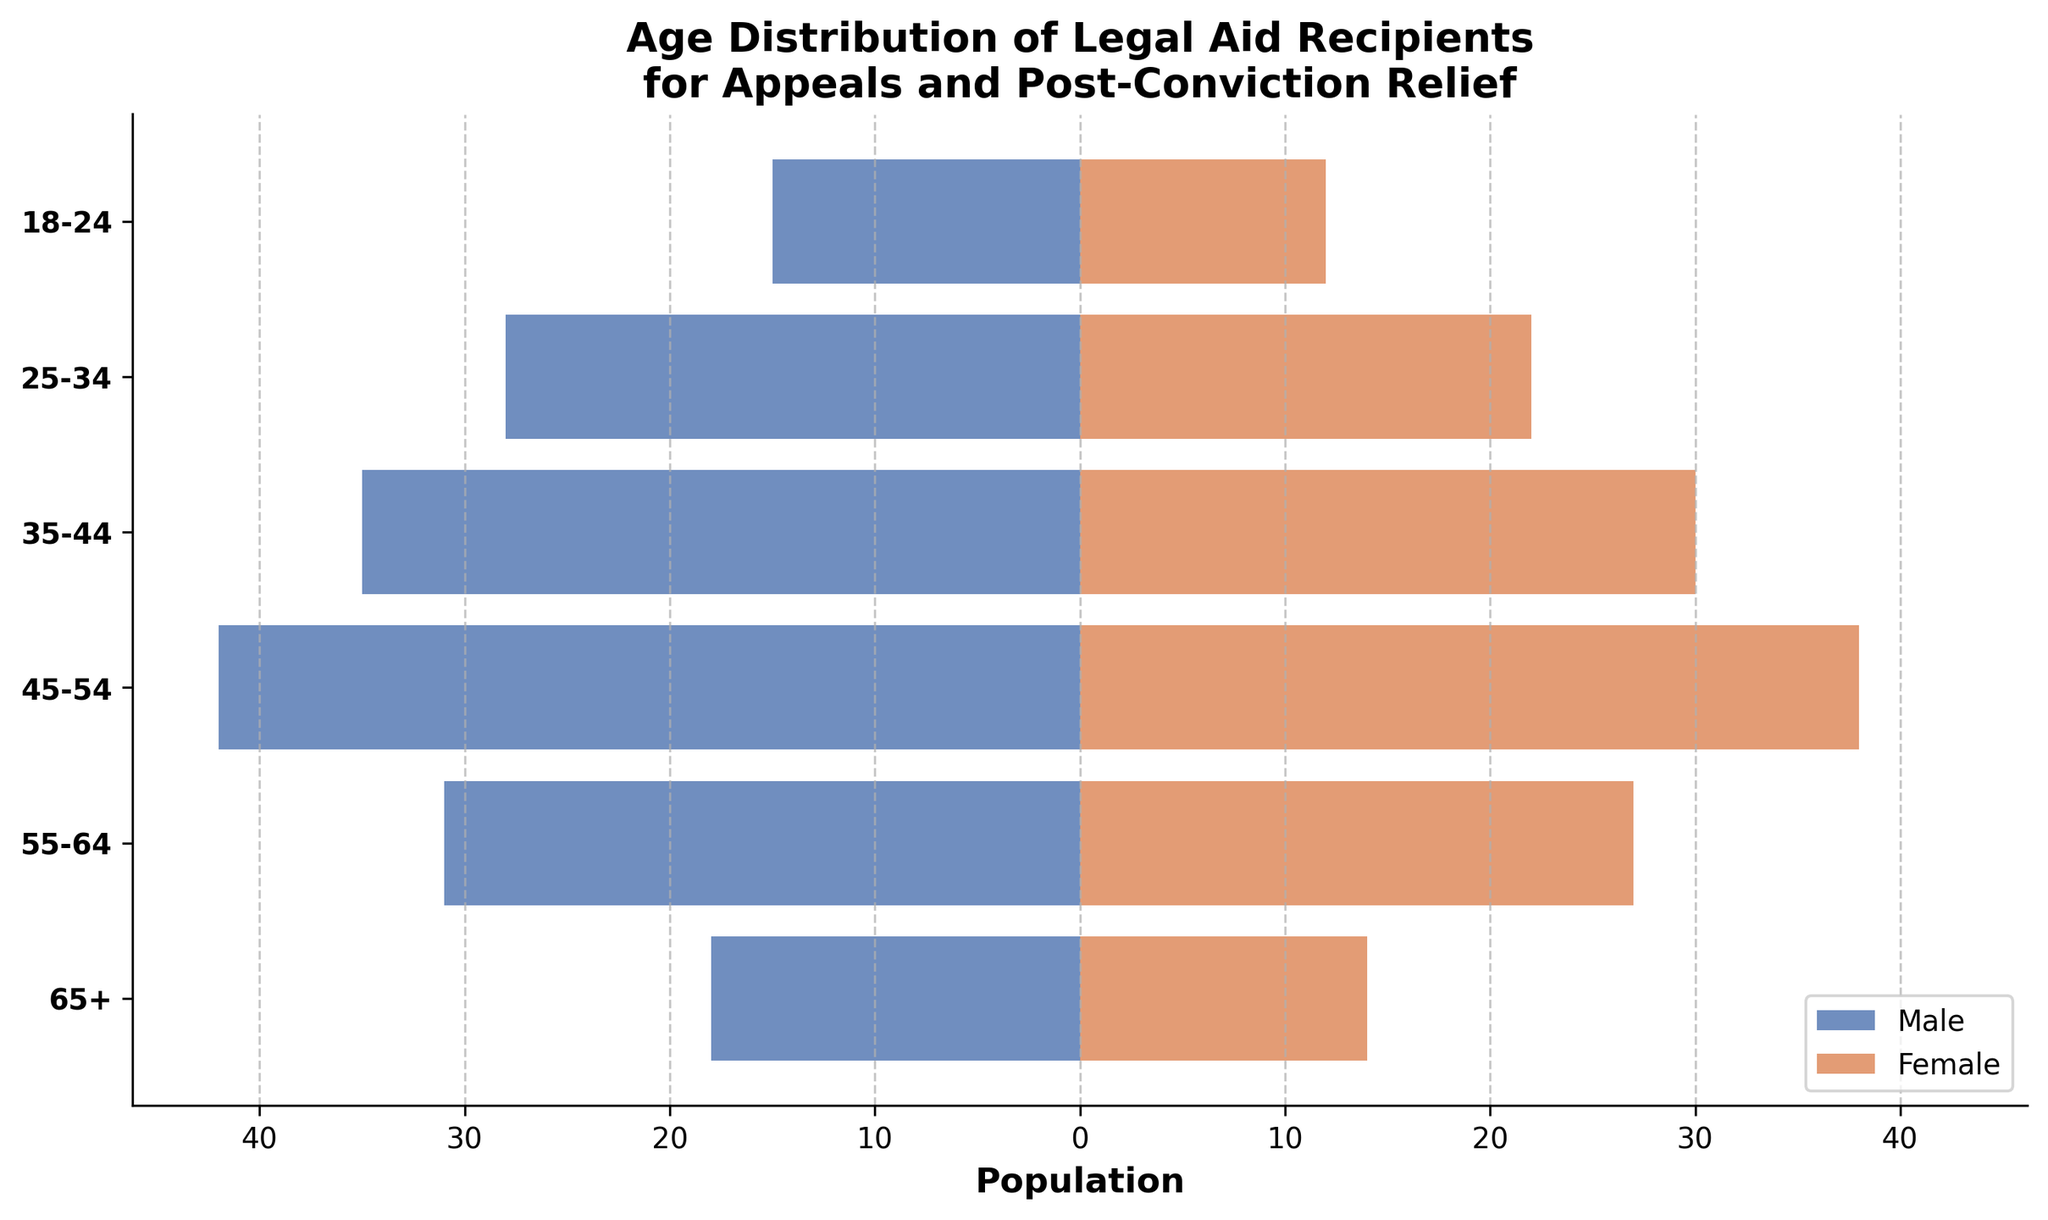What is the title of the figure? The title is usually displayed at the top of the figure. In this case, it clearly states the subject of the data presented.
Answer: Age Distribution of Legal Aid Recipients for Appeals and Post-Conviction Relief What age group has the highest number of males receiving legal aid? Look for the longest bar on the male side and identify its corresponding age group on the y-axis.
Answer: 45-54 What is the total number of females in the 35-44 and 45-54 age groups? Find the values for females in these two age groups and add them together. 35-44 has 30, and 45-54 has 38. So, the total is 30 + 38.
Answer: 68 Which gender has more recipients in the 55-64 age group? Compare the lengths of the bars for males and females in the 55-64 age group.
Answer: Male How many males aged 18-24 are there? Look at the length of the bar corresponding to 18-24 on the male side. The value displayed at the end of the bar is the answer.
Answer: 15 What is the difference in the number of legal aid recipients between males and females in the 65+ age group? Find the values for both males and females in the 65+ age group. Difference is calculated as 18 (males) - 14 (females).
Answer: 4 In which age group is the female population closest to the male population? Compare the values for males and females across all age groups and find the smallest difference.
Answer: 18-24 What is the total number of male and female recipients in the 45-54 age group combined? Add the number of males and females in this age group. Males are 42 and females are 38. So, the total is 42 + 38.
Answer: 80 Which age group has the least number of females receiving legal aid? Identify the shortest bar on the female side and match it with the corresponding age group on the y-axis.
Answer: 18-24 How does the total number of males compare to the total number of females across all age groups? Summing up all values for males and females separately and then comparing the totals. Males: 15+28+35+42+31+18 = 169; Females: 12+22+30+38+27+14 = 143. Males: 169, Females: 143. Males have more recipients.
Answer: Males have more 